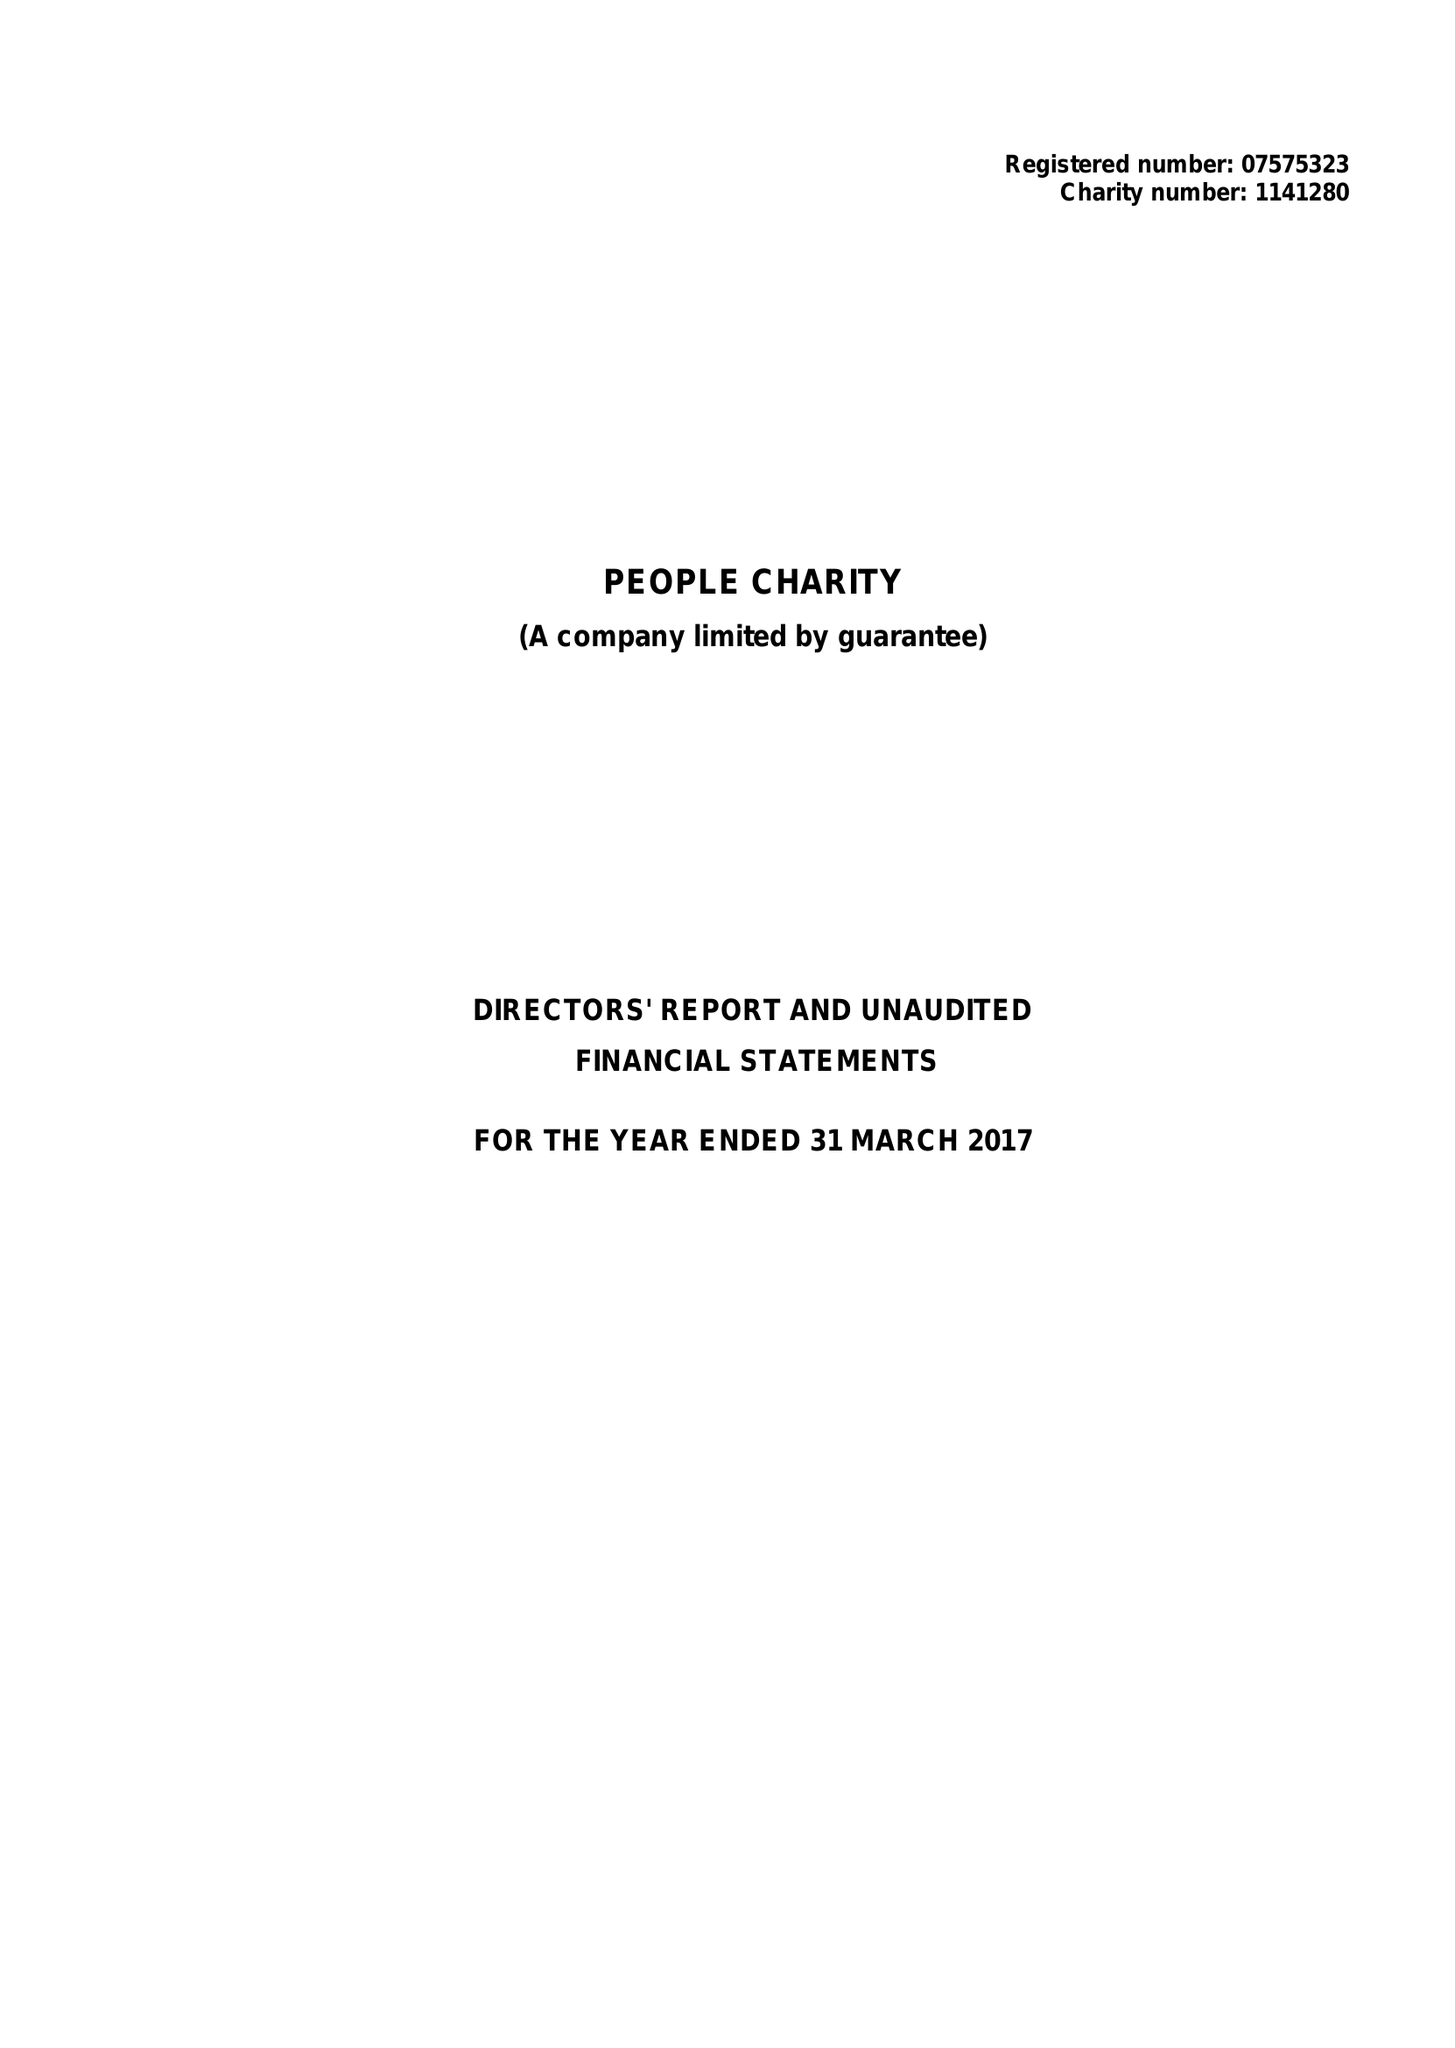What is the value for the address__post_town?
Answer the question using a single word or phrase. LONDON 